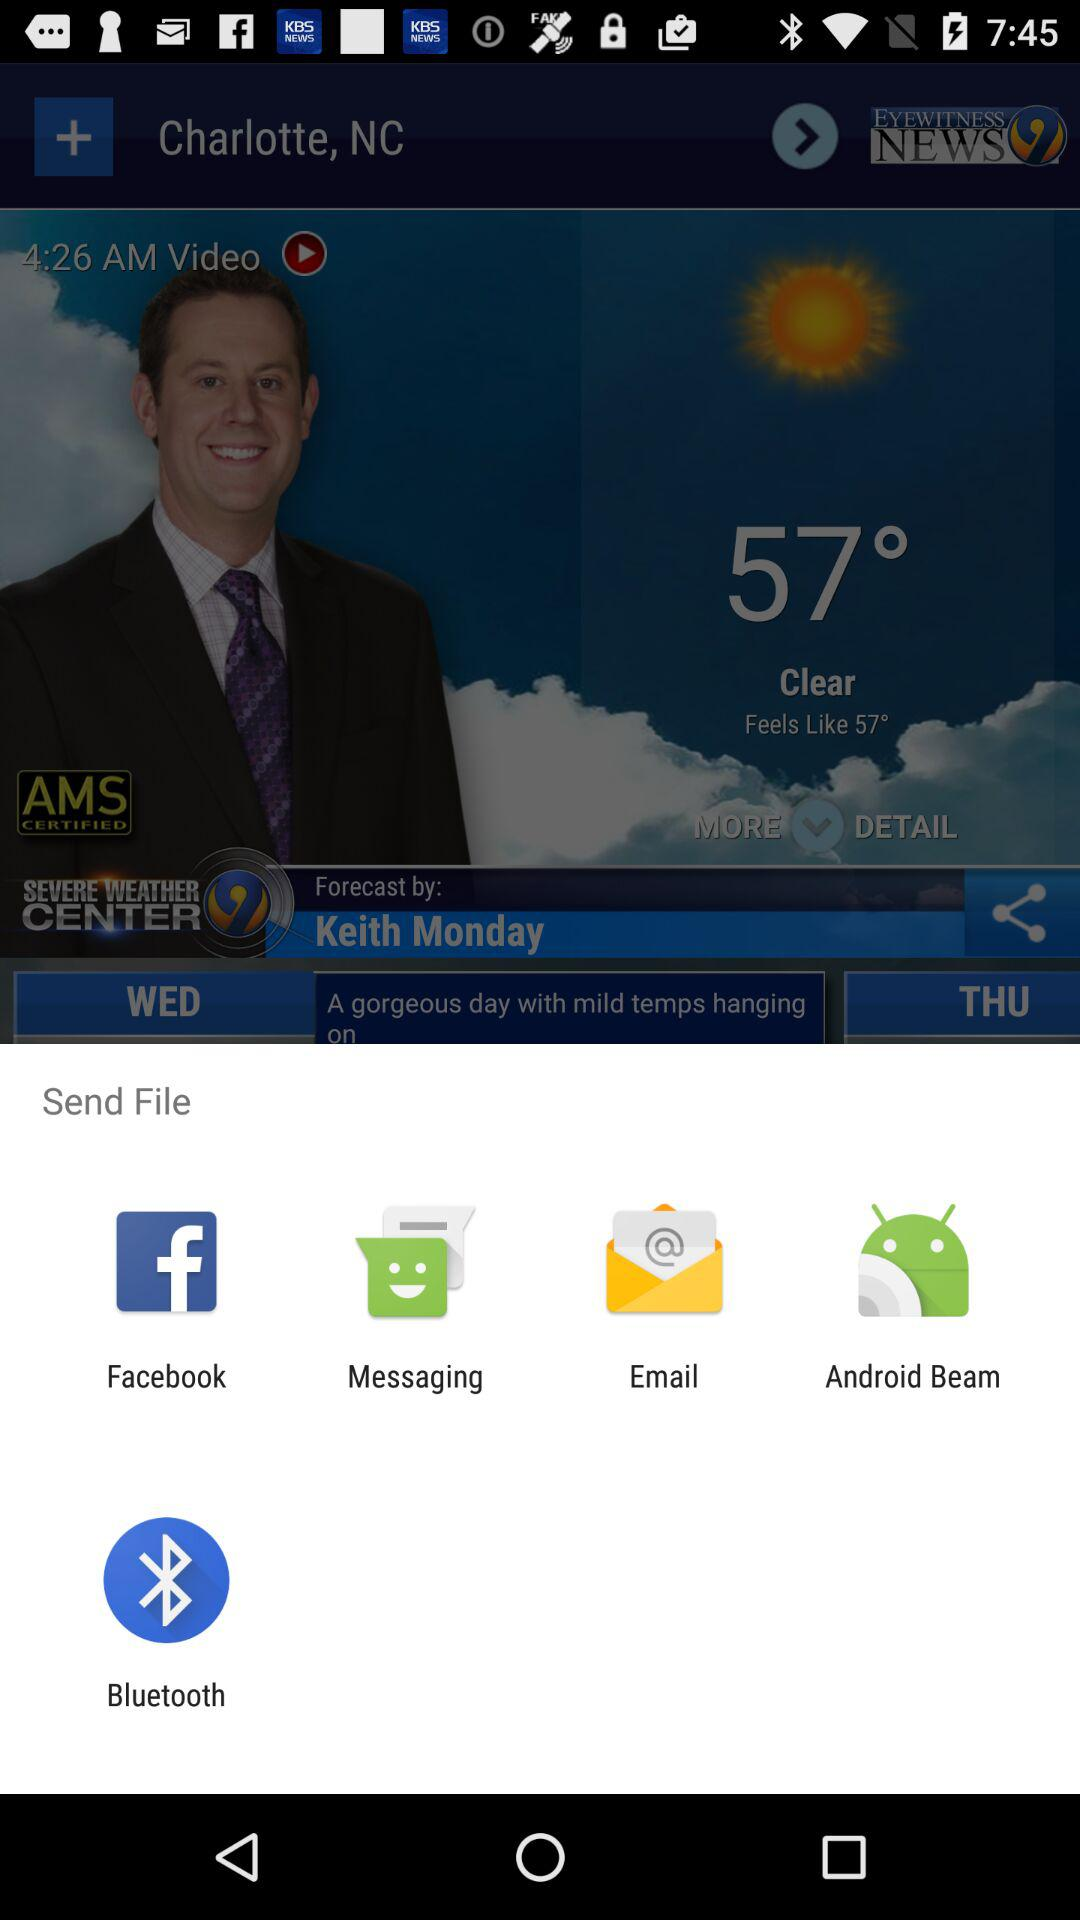From which app can we share it? The apps we can share with them are "Facebook", "Messaging", "Email", "Android Beam", and "Bluetooth". 